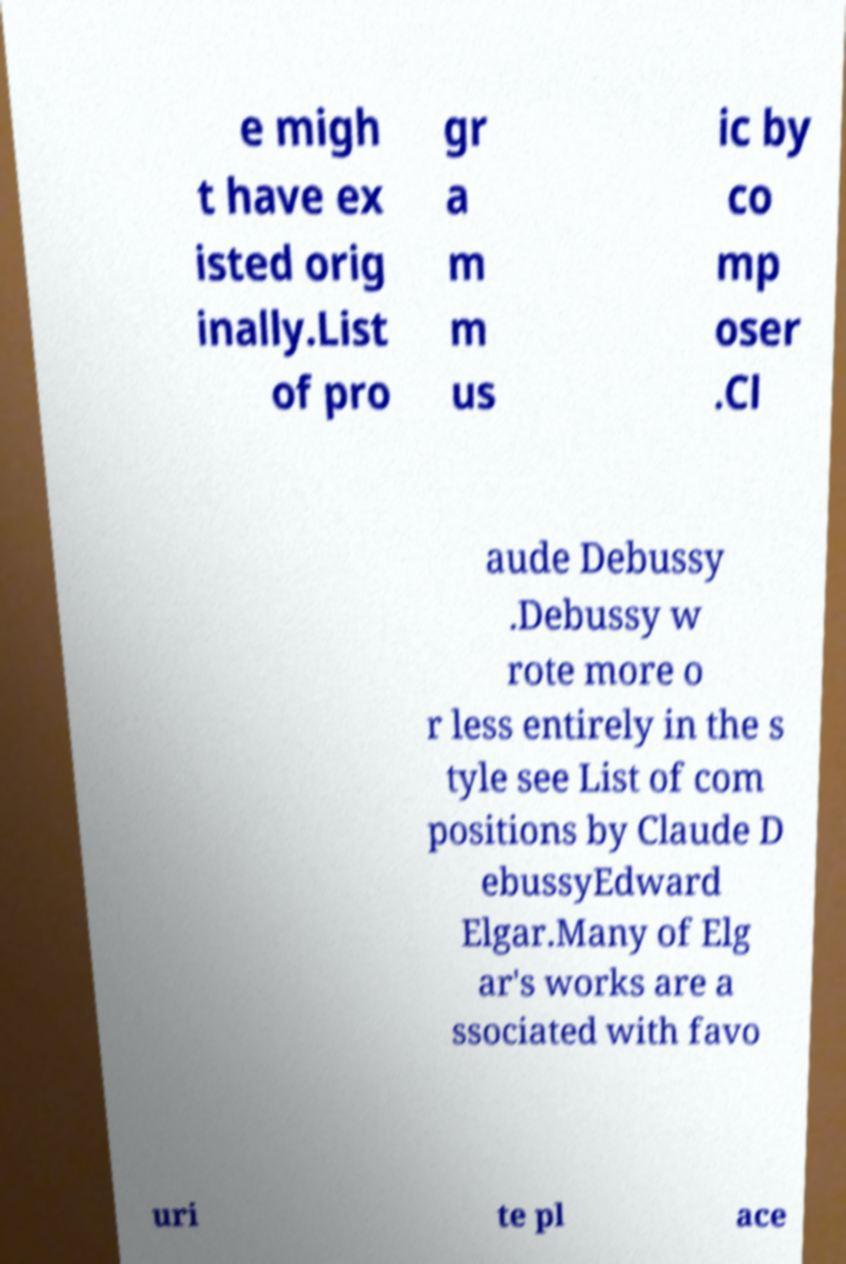For documentation purposes, I need the text within this image transcribed. Could you provide that? e migh t have ex isted orig inally.List of pro gr a m m us ic by co mp oser .Cl aude Debussy .Debussy w rote more o r less entirely in the s tyle see List of com positions by Claude D ebussyEdward Elgar.Many of Elg ar's works are a ssociated with favo uri te pl ace 